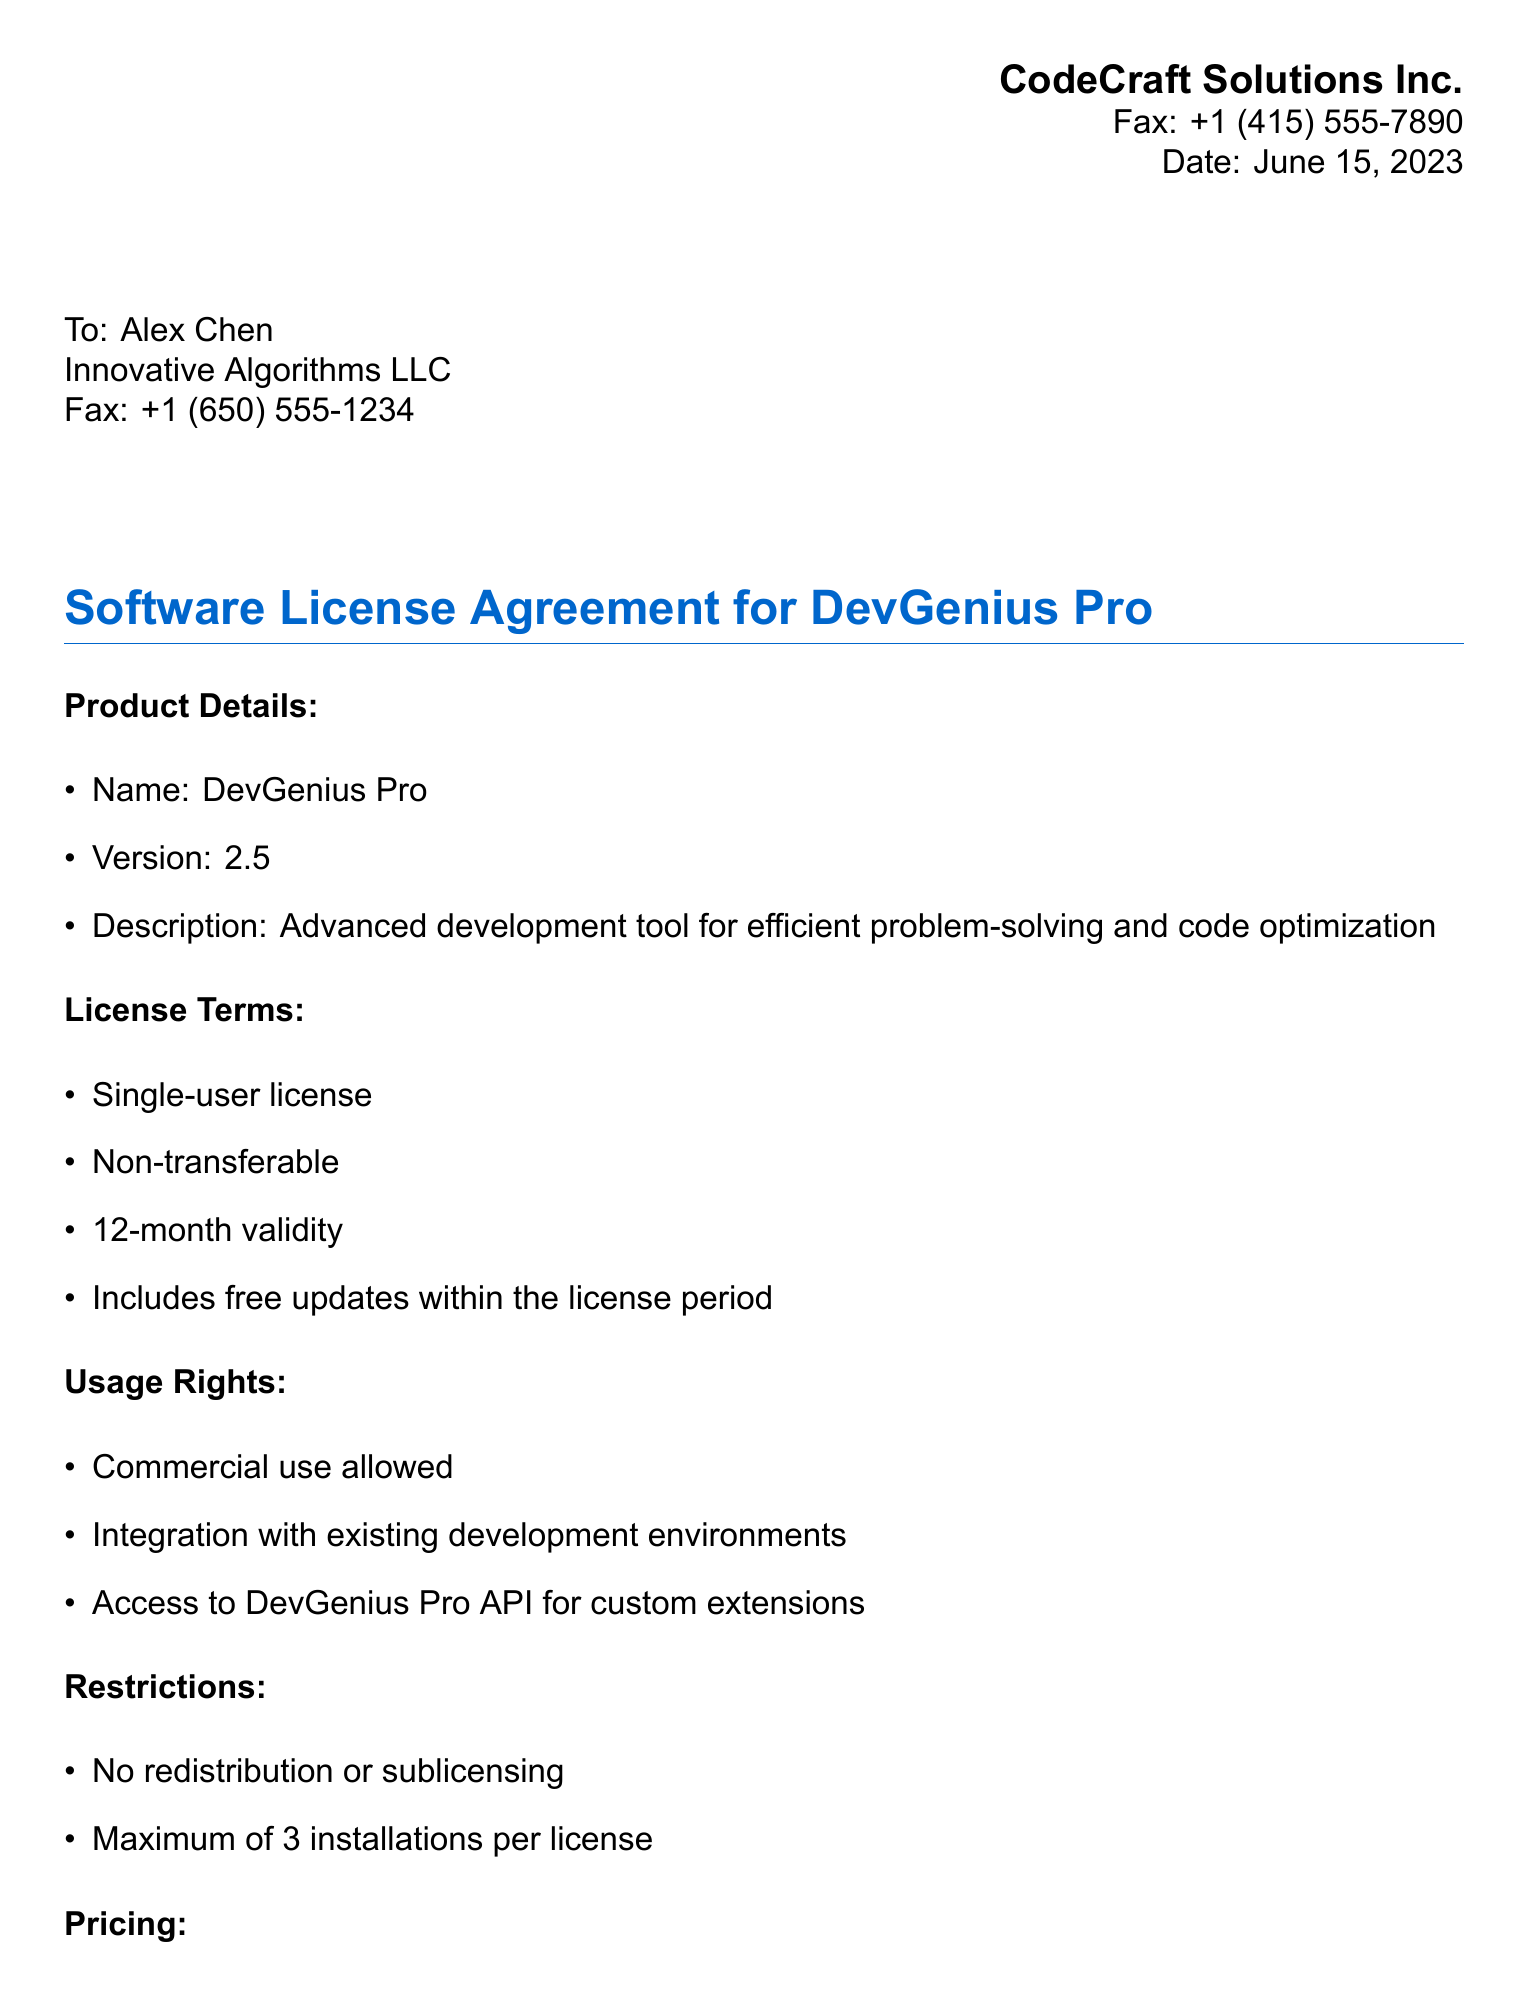What is the name of the product? The name of the product is stated in the document as "DevGenius Pro."
Answer: DevGenius Pro What is the version of the software? The document specifies the version of the software as "2.5."
Answer: 2.5 What is the base price for the license? The base price for the license can be found in the pricing section as "$599 per year."
Answer: $599 per year How long is the license validity? The license validity is explicitly mentioned in the license terms as "12-month validity."
Answer: 12-month validity What is the discount percentage for bulk licenses? The document states that the bulk discount is "15% off for 5+ licenses."
Answer: 15% What are the accepted payment methods? The accepted payment methods are listed as "Credit card, Wire transfer, Purchase order."
Answer: Credit card, Wire transfer, Purchase order Is commercial use allowed? The usage rights section indicates that commercial use is "allowed."
Answer: Allowed What is the maximum number of installations per license? The restrictions specify that the maximum number of installations per license is "3 installations."
Answer: 3 installations Who is the licensee? The document identifies the licensee as "Alex Chen."
Answer: Alex Chen What is the optional support plan cost? The pricing section indicates that the cost for the support plan is "$99 per year."
Answer: $99 per year 